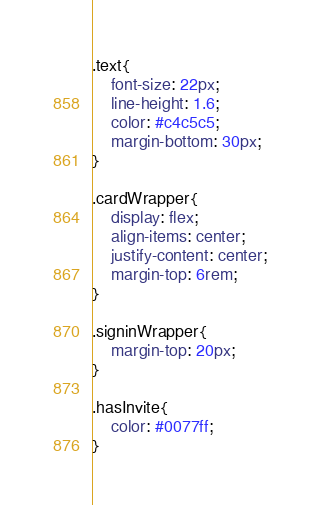<code> <loc_0><loc_0><loc_500><loc_500><_CSS_>.text{
    font-size: 22px;
    line-height: 1.6;
    color: #c4c5c5;
    margin-bottom: 30px;
}

.cardWrapper{
    display: flex;
    align-items: center;
    justify-content: center;
    margin-top: 6rem;
}

.signinWrapper{
    margin-top: 20px;
}

.hasInvite{
    color: #0077ff;
}

</code> 